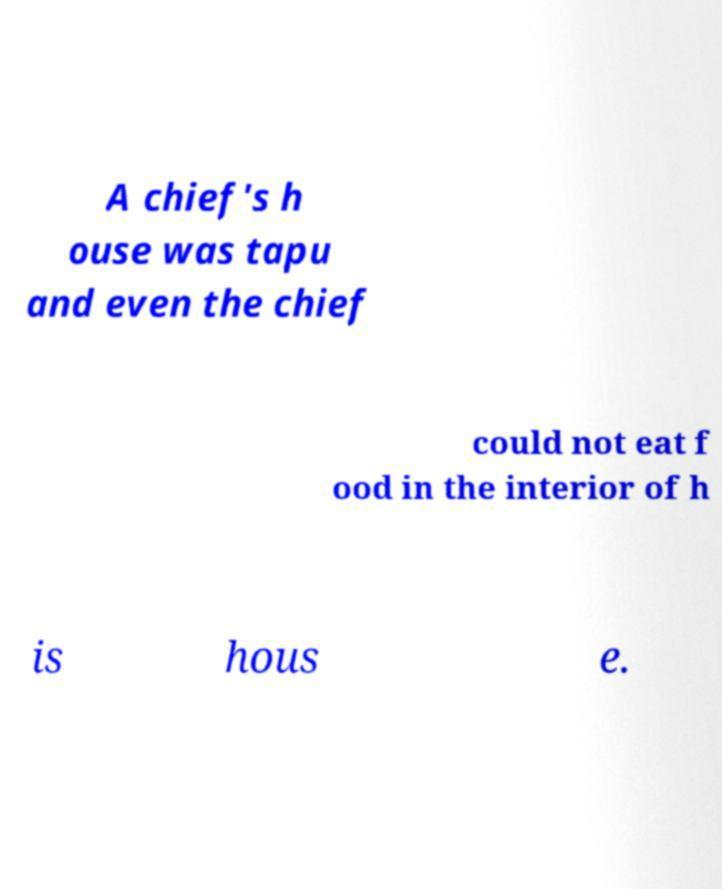Could you extract and type out the text from this image? A chief's h ouse was tapu and even the chief could not eat f ood in the interior of h is hous e. 